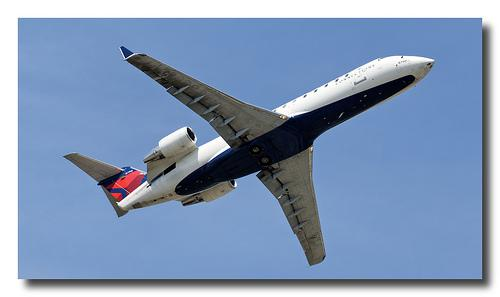Question: what colours are on the tail?
Choices:
A. Green and orange.
B. Yellow and purple.
C. Blue and red.
D. Auburn and white.
Answer with the letter. Answer: C Question: where is the plane?
Choices:
A. Lost in time.
B. Flying in front of the sun.
C. On sabbatical.
D. The sky.
Answer with the letter. Answer: D Question: how many wings are visible?
Choices:
A. 3.
B. 4.
C. 5.
D. 2.
Answer with the letter. Answer: D Question: how many tail wings are visible?
Choices:
A. 2.
B. 1.
C. 3.
D. 4.
Answer with the letter. Answer: B Question: what corner is the night see of the plane facing?
Choices:
A. Left bottom.
B. Upper right.
C. Top left.
D. Top right.
Answer with the letter. Answer: D 